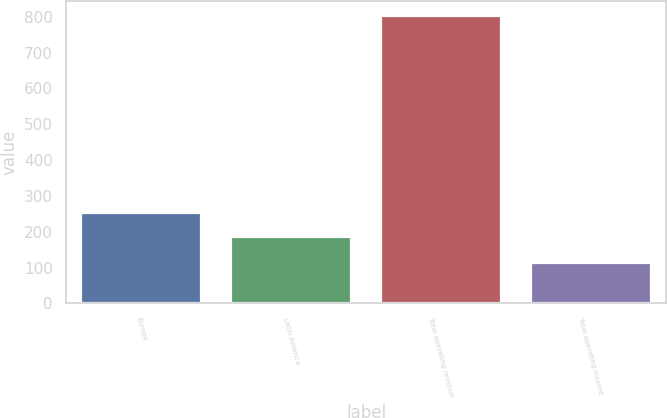Convert chart. <chart><loc_0><loc_0><loc_500><loc_500><bar_chart><fcel>Europe<fcel>Latin America<fcel>Total operating revenue<fcel>Total operating income<nl><fcel>253.6<fcel>183.9<fcel>803.6<fcel>111.4<nl></chart> 